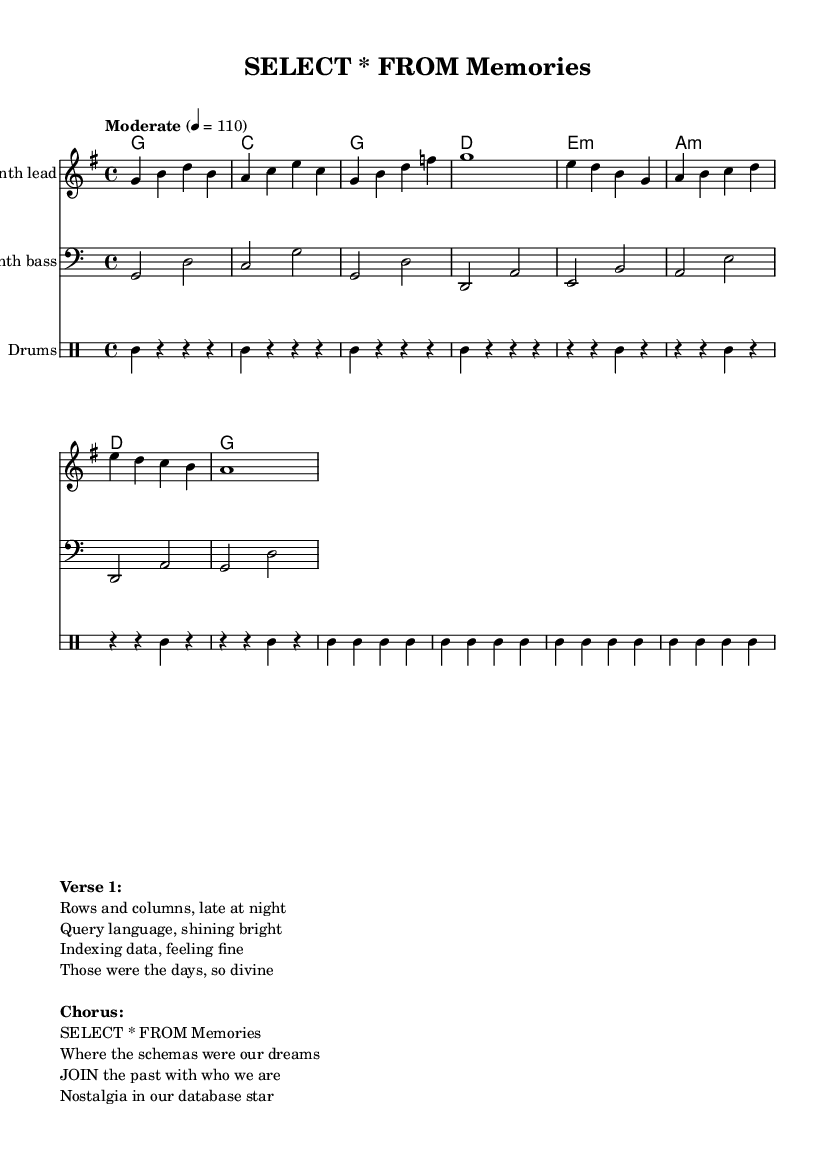What is the key signature of this music? The key signature is indicated by the absence of sharps or flats in the music, which suggests a G major key, as G major has one sharp, but it is not shown in this score.
Answer: G major What is the time signature of this music? The time signature is shown at the beginning of the score and is expressed as a fraction; it is 4 over 4, which means there are four beats per measure and the quarter note gets one beat.
Answer: 4/4 What is the tempo marking for this music? The tempo marking is located above the staff; it states "Moderate" with a specific beats-per-minute indication of 110. This tells us the speed at which the piece should be performed.
Answer: 110 How many measures are in the melody? By counting the individual measures in the melody section, it can be seen that there are a total of eight distinct measures presented. Each measure is separated by a vertical bar line.
Answer: 8 What instruments are involved in this piece? The specific instruments are indicated above each staff; there is a "Synth lead," a "Synth bass," and a "Drums" section showing the types of instruments played throughout the score.
Answer: Synth lead, Synth bass, Drums Which section contains the lyrics? The lyrics are marked in the "markup" section at the bottom of the code; they are presented as verse and chorus lines, making it clear that it contains textual elements associated with the music.
Answer: Verse 1 and Chorus What is the theme of the lyrics presented in this music? The lyrics describe nostalgic experiences related to database administration, referencing memories, schemas, and nostalgia in databases, which gives it a unique theme relevant to those who understand data administration.
Answer: Nostalgia in database administration 